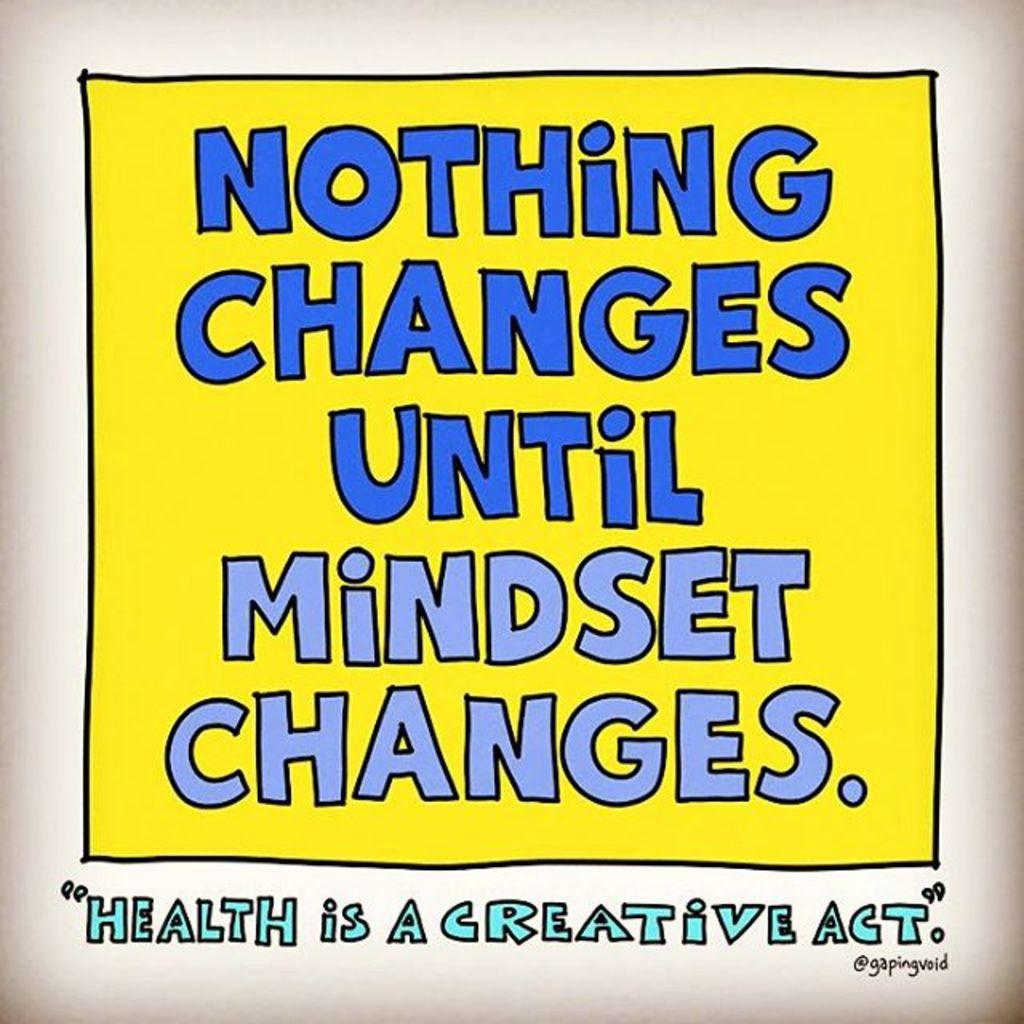Provide a one-sentence caption for the provided image. A sign states "Nothing Changes Until Mindset Changes.". 